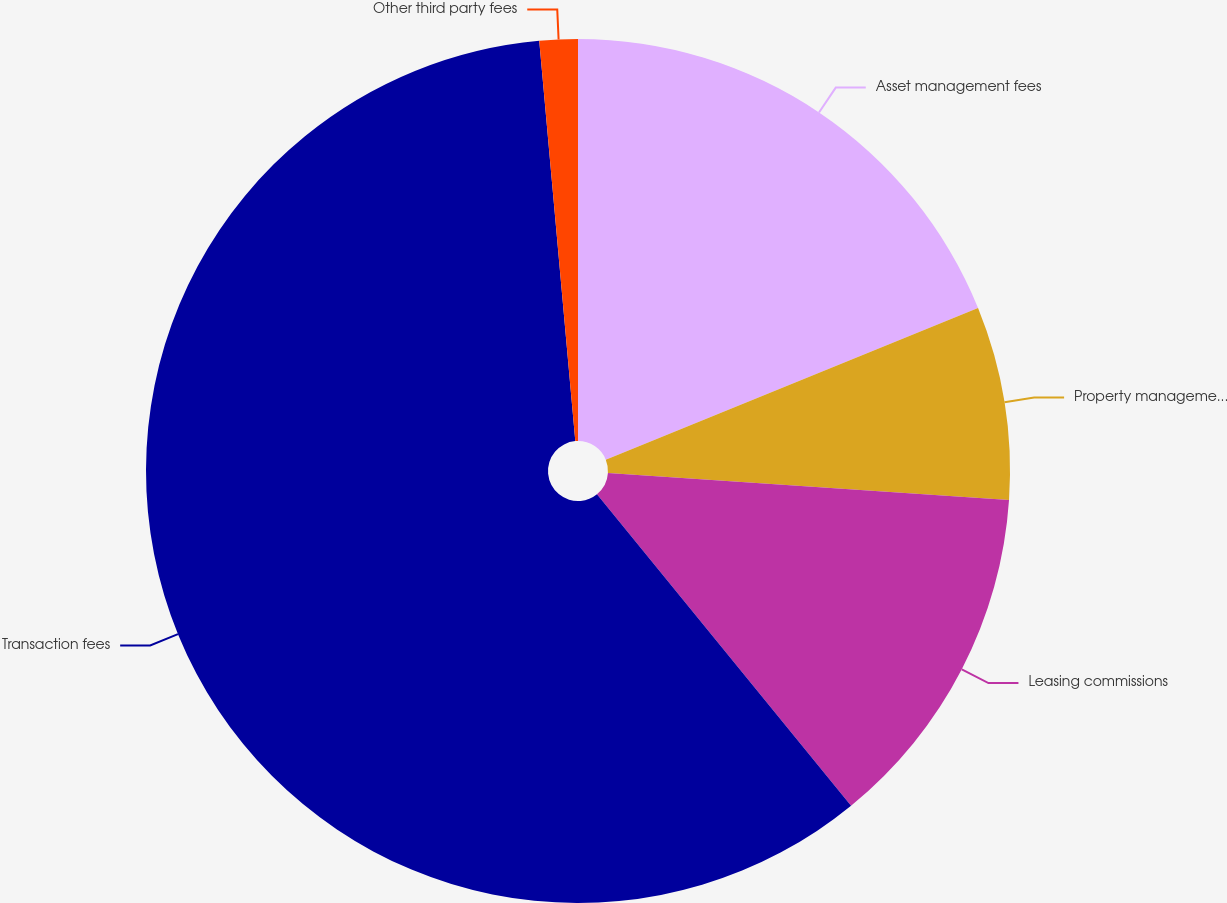Convert chart to OTSL. <chart><loc_0><loc_0><loc_500><loc_500><pie_chart><fcel>Asset management fees<fcel>Property management fees<fcel>Leasing commissions<fcel>Transaction fees<fcel>Other third party fees<nl><fcel>18.84%<fcel>7.23%<fcel>13.04%<fcel>59.46%<fcel>1.43%<nl></chart> 